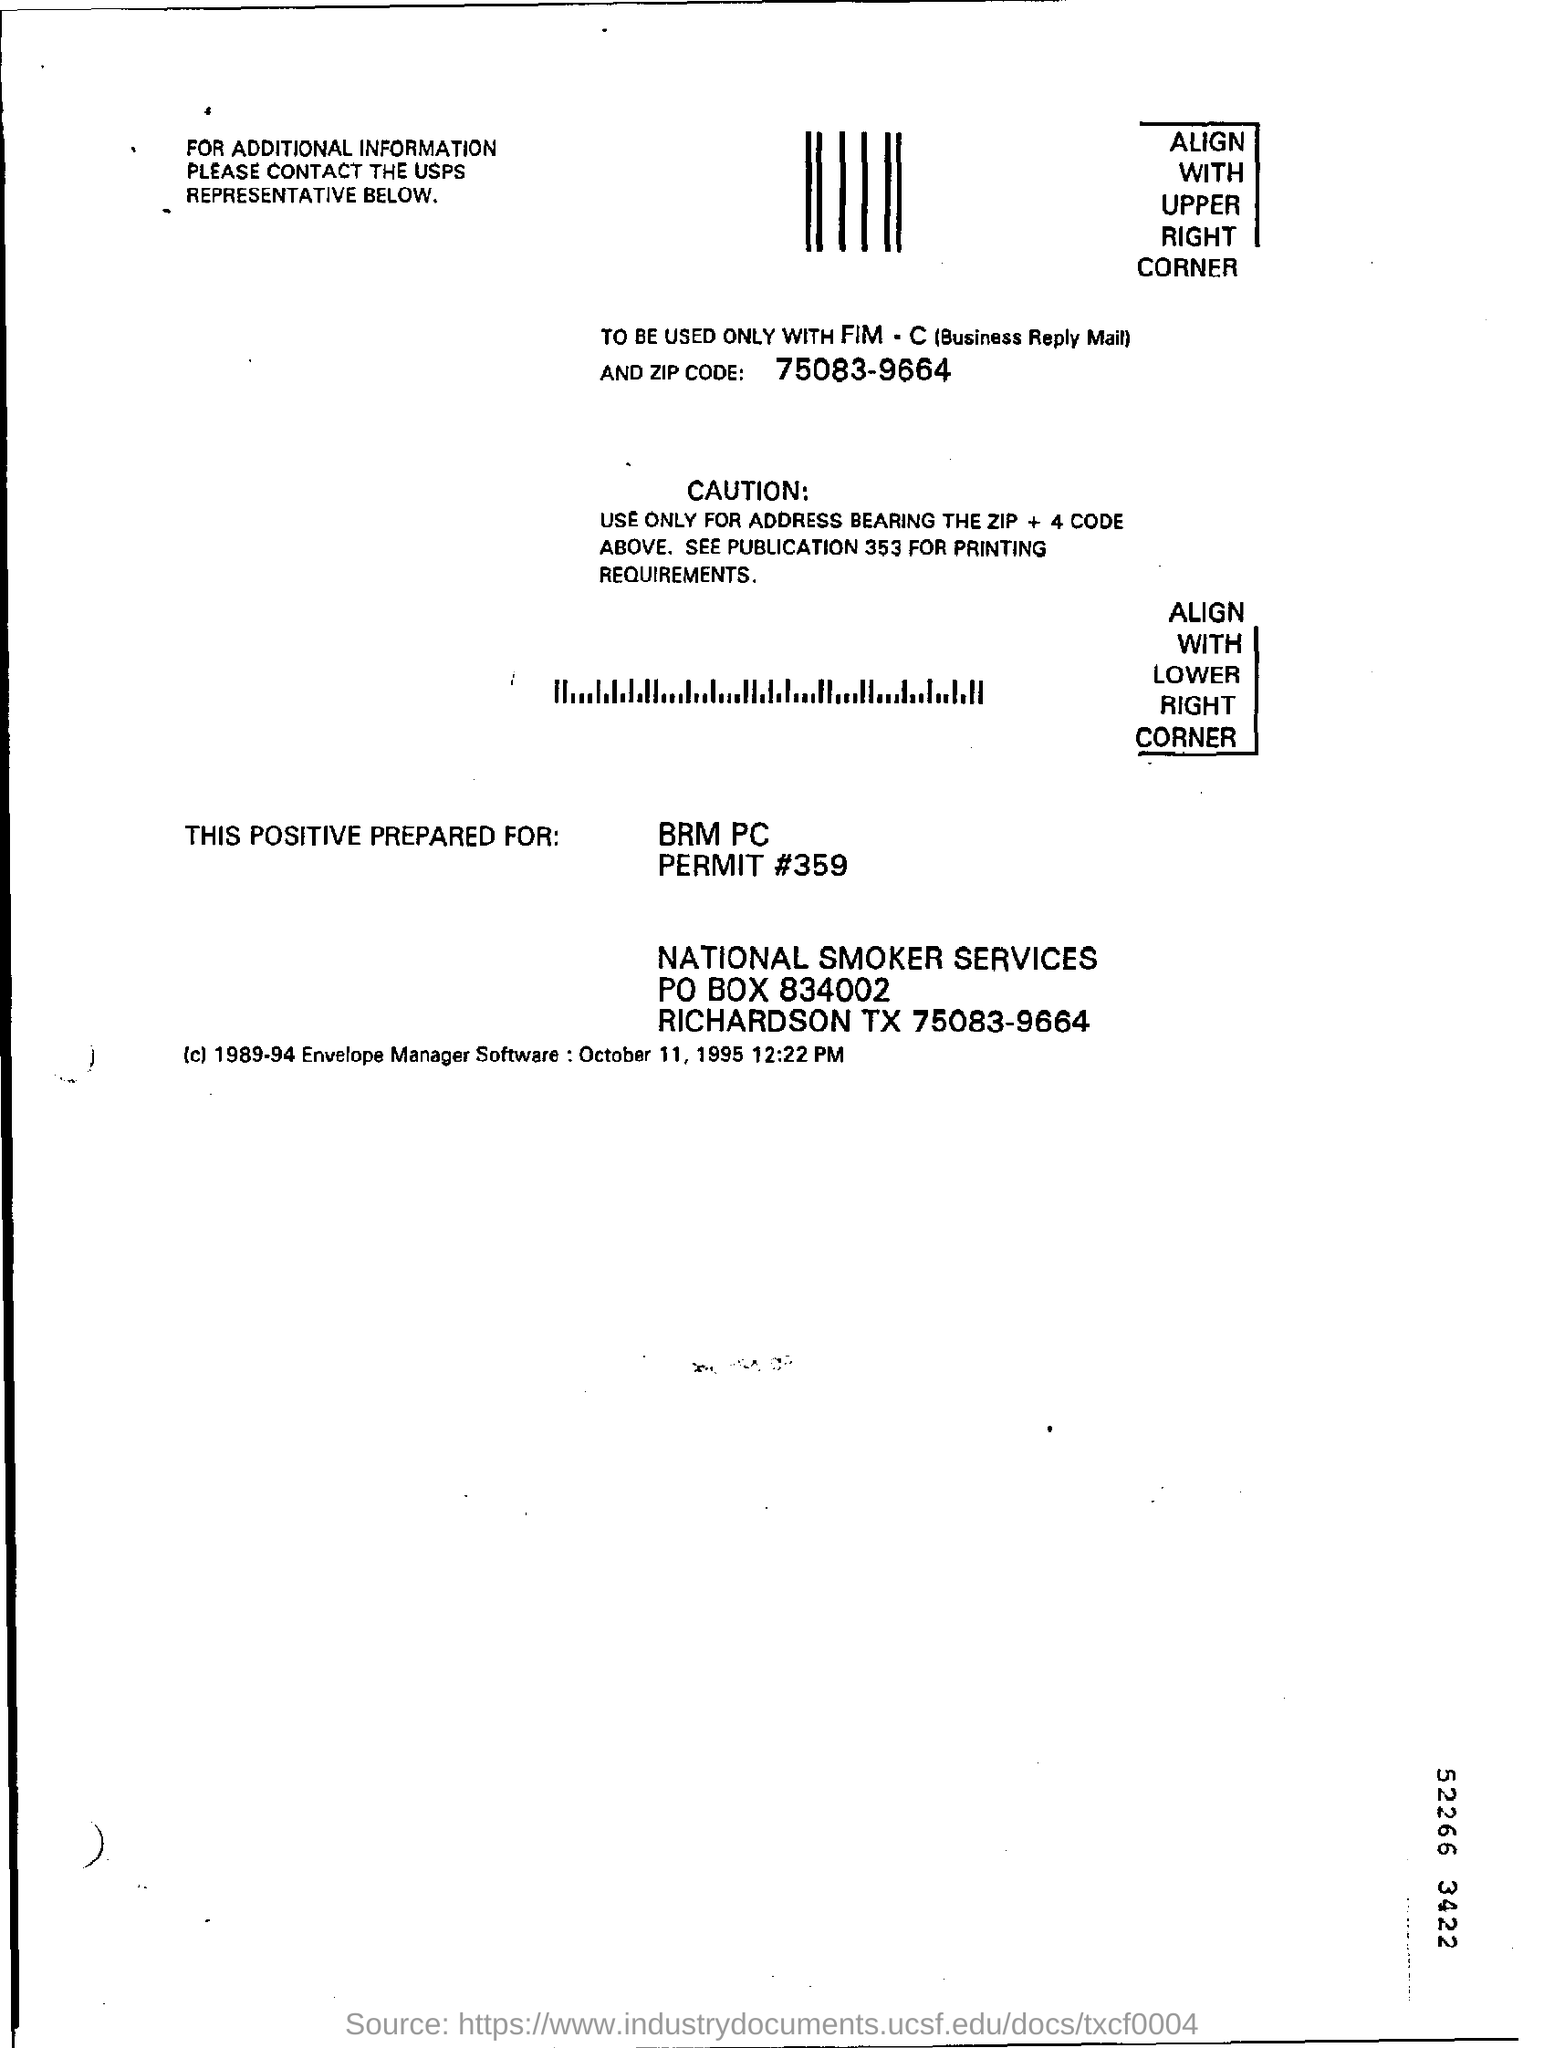What is the PO box number?
Provide a succinct answer. 834002. What is the zip code mentioned in the mail?
Ensure brevity in your answer.  75083-9664. What is the permit number?
Your answer should be very brief. 359. 